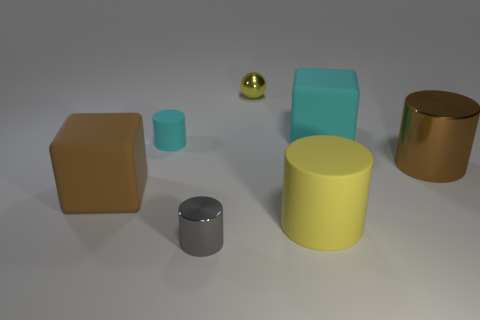Add 3 gray cylinders. How many objects exist? 10 Subtract all blocks. How many objects are left? 5 Subtract 0 gray balls. How many objects are left? 7 Subtract all matte blocks. Subtract all large brown cylinders. How many objects are left? 4 Add 4 large metallic cylinders. How many large metallic cylinders are left? 5 Add 4 tiny matte cylinders. How many tiny matte cylinders exist? 5 